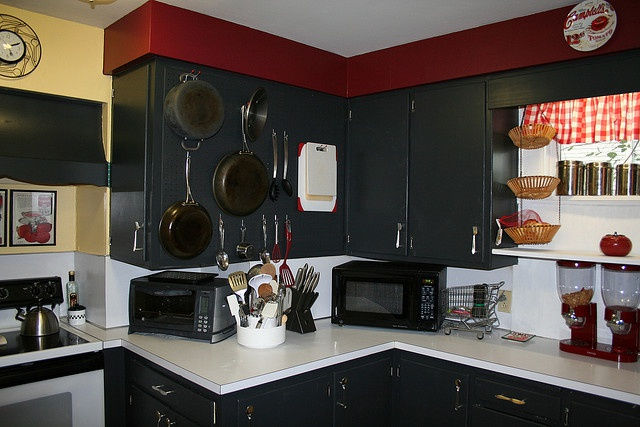Describe the objects in this image and their specific colors. I can see oven in gray, black, and darkgray tones, microwave in gray, black, and purple tones, clock in gray, tan, black, and khaki tones, spoon in gray, black, and darkgray tones, and spoon in gray, black, darkgray, and lightgray tones in this image. 